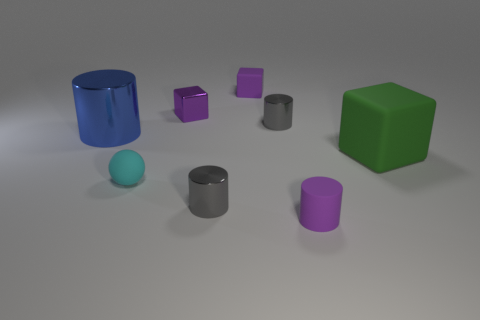Is there any other thing that is the same shape as the cyan thing?
Keep it short and to the point. No. What is the material of the cyan ball?
Your answer should be very brief. Rubber. There is a purple shiny block; are there any small cyan things in front of it?
Provide a short and direct response. Yes. Do the large blue object and the big green matte object have the same shape?
Offer a terse response. No. What number of other objects are there of the same size as the cyan thing?
Your response must be concise. 5. What number of objects are cylinders that are behind the tiny rubber cylinder or green things?
Your answer should be very brief. 4. What is the color of the small ball?
Ensure brevity in your answer.  Cyan. There is a thing on the left side of the cyan matte sphere; what material is it?
Keep it short and to the point. Metal. There is a green rubber thing; is its shape the same as the object on the left side of the small sphere?
Your answer should be compact. No. Are there more large blue objects than purple things?
Keep it short and to the point. No. 